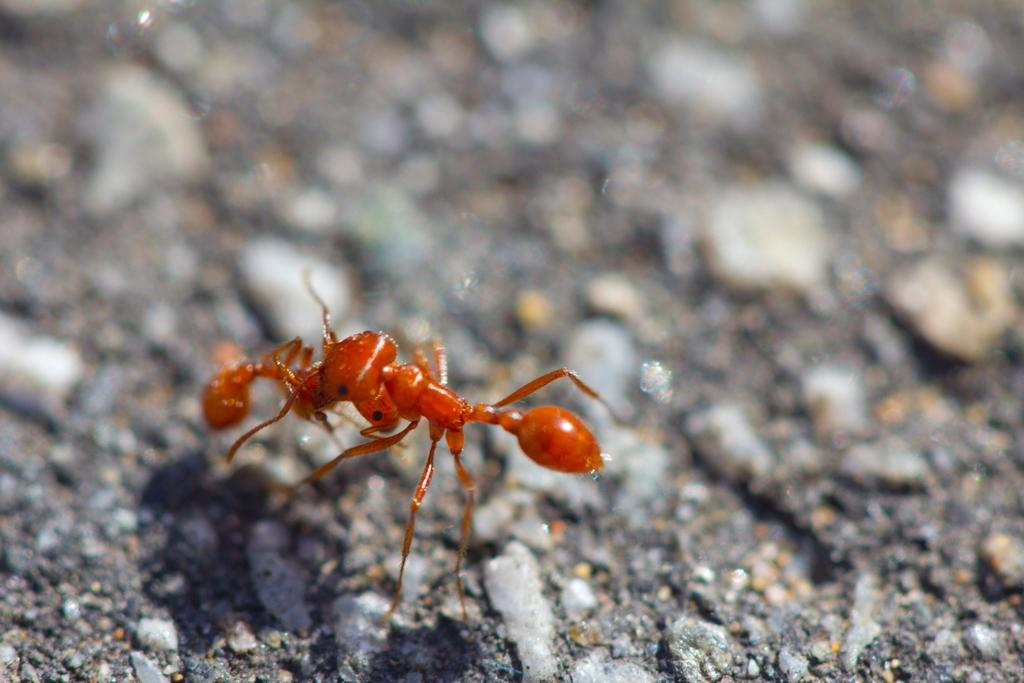What type of creature is in the image? There is an insect in the image. What color is the insect? The insect is brown in color. Can you describe the background of the image? The background of the image is blurred. Where is the basketball located in the image? There is no basketball present in the image. What type of spot can be seen on the insect's body in the image? There is no mention of any spots on the insect's body in the provided facts. 